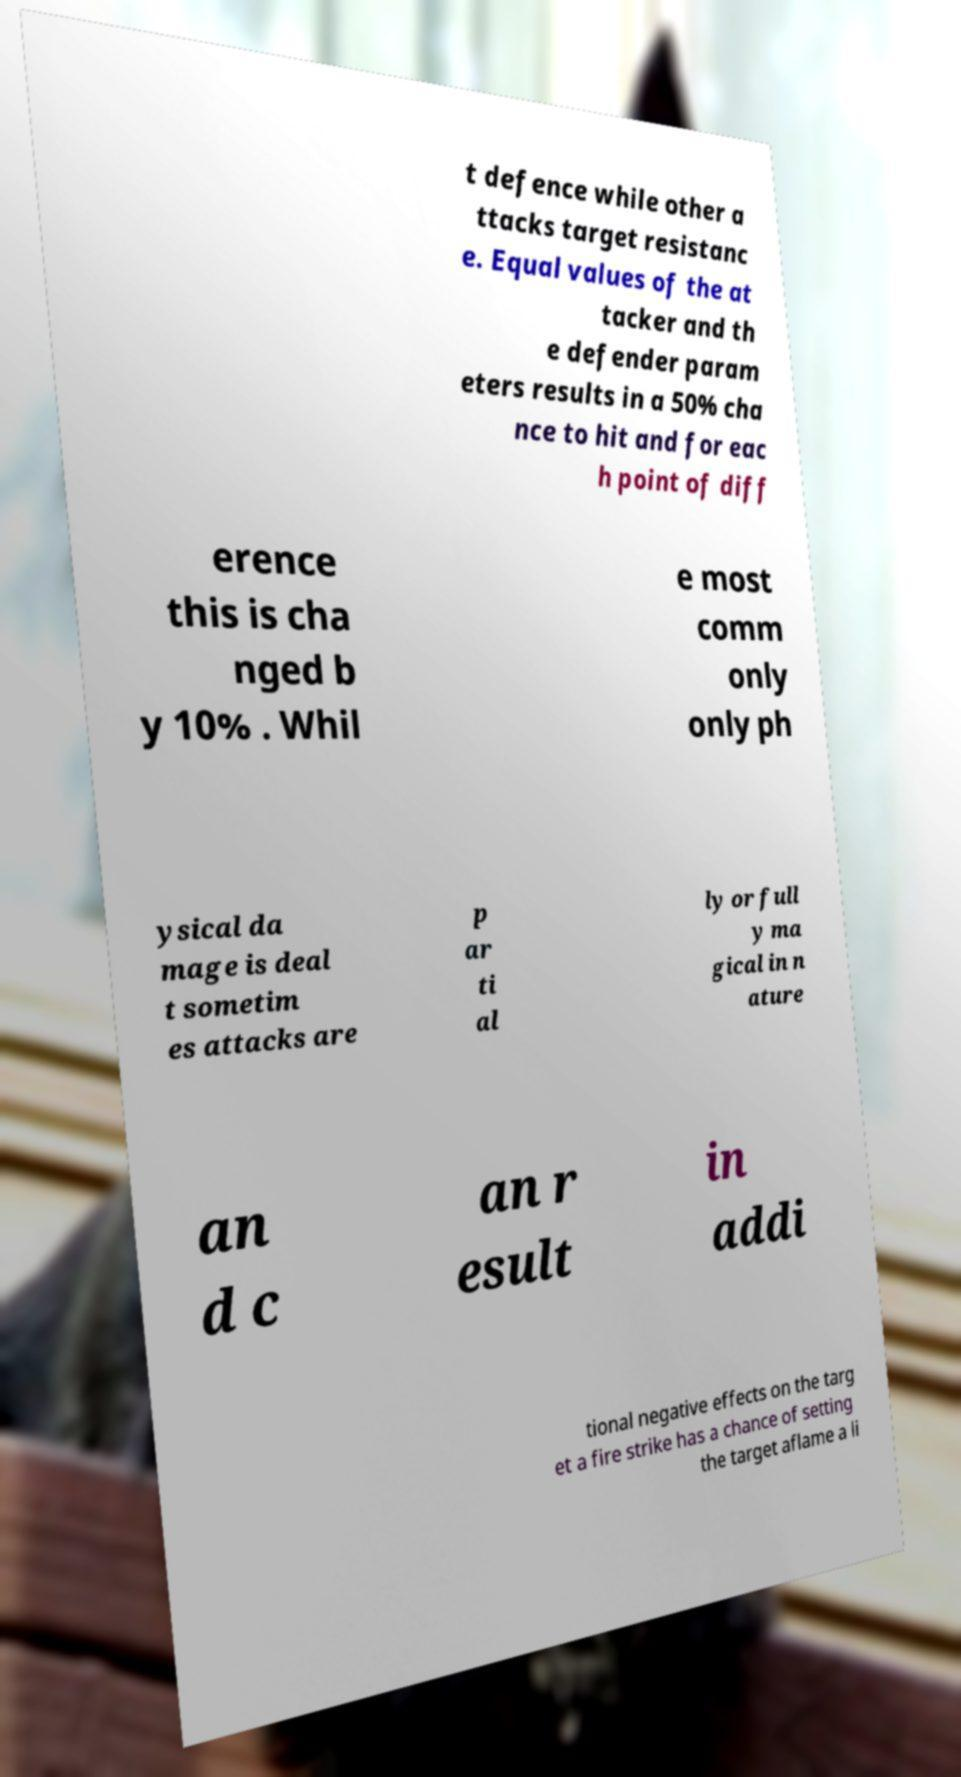Could you extract and type out the text from this image? t defence while other a ttacks target resistanc e. Equal values of the at tacker and th e defender param eters results in a 50% cha nce to hit and for eac h point of diff erence this is cha nged b y 10% . Whil e most comm only only ph ysical da mage is deal t sometim es attacks are p ar ti al ly or full y ma gical in n ature an d c an r esult in addi tional negative effects on the targ et a fire strike has a chance of setting the target aflame a li 